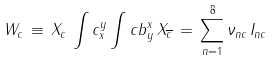Convert formula to latex. <formula><loc_0><loc_0><loc_500><loc_500>W _ { c } \, \equiv \, X _ { c } \, \int c _ { x } ^ { y } \int c b _ { y } ^ { x } \, X _ { \overline { c } } \, = \, \sum _ { n = 1 } ^ { 8 } \nu _ { n c } \, I _ { n c }</formula> 